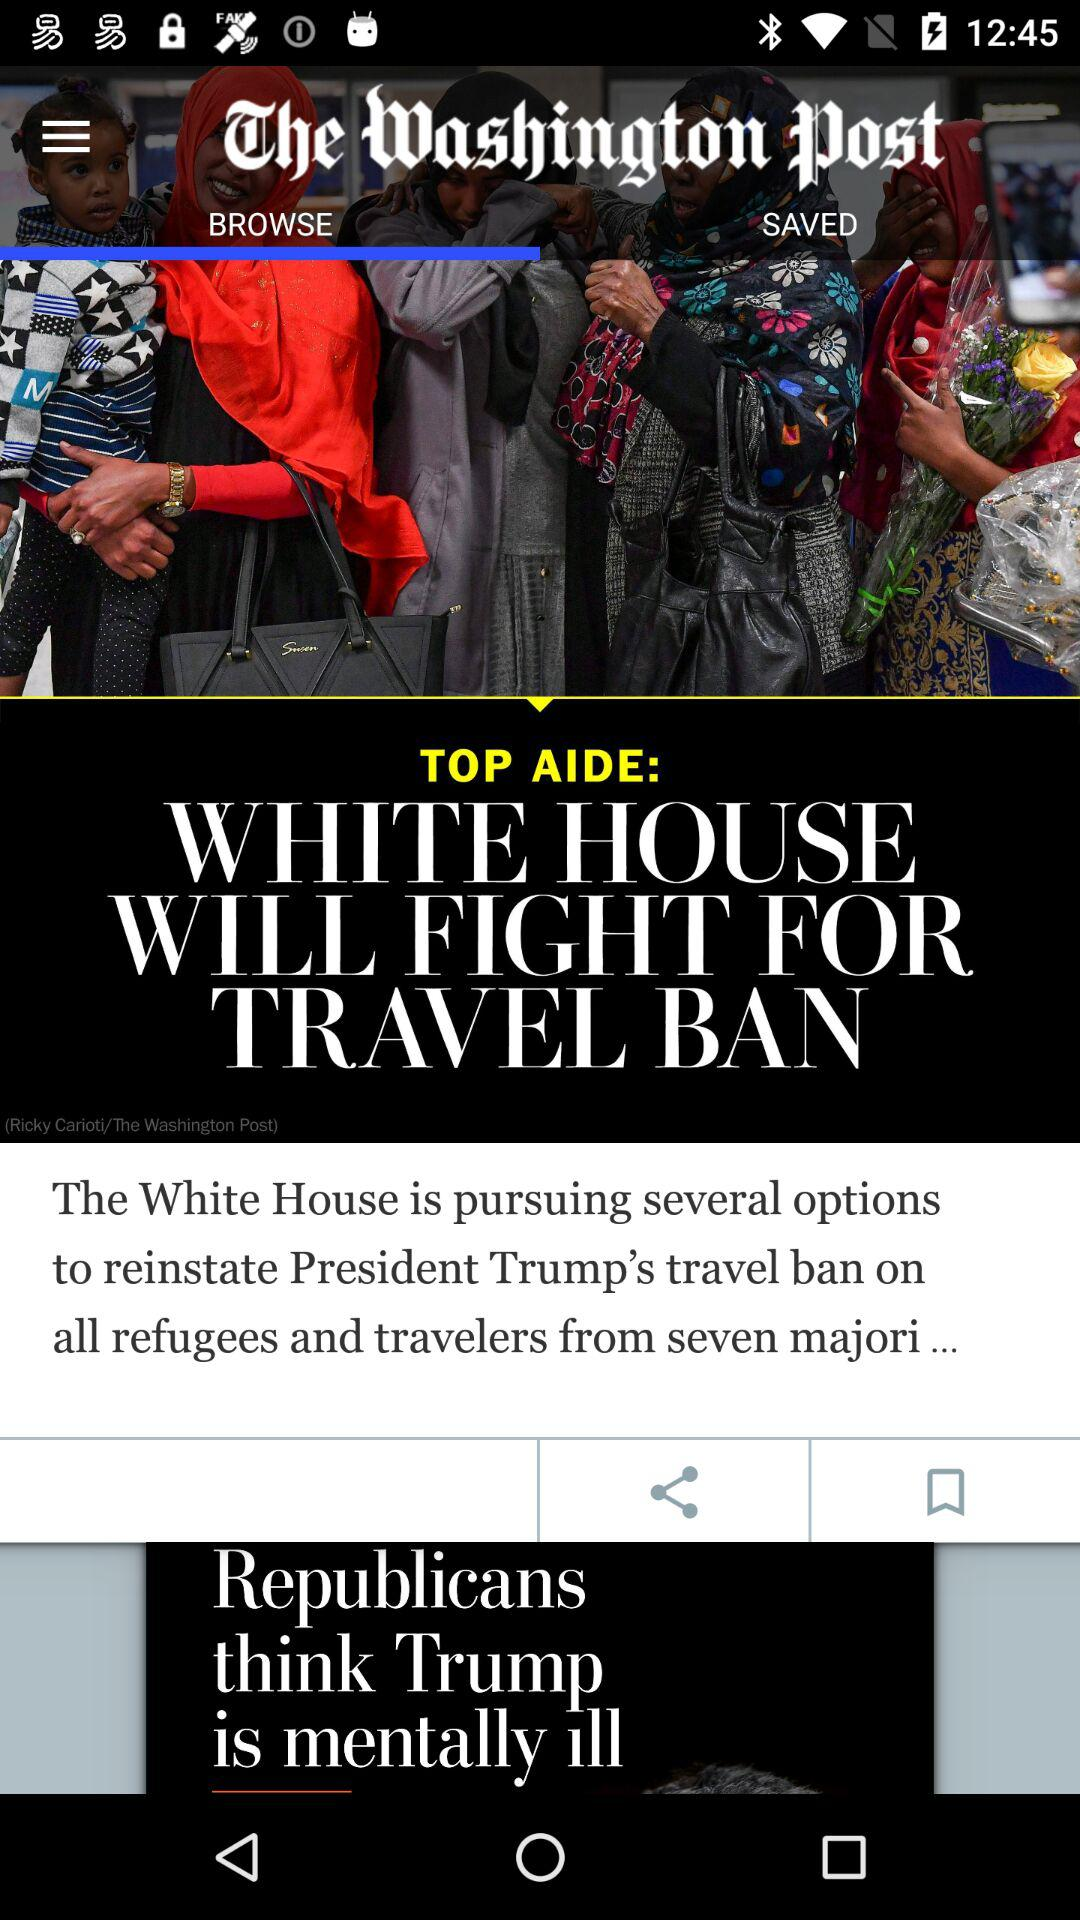What is the application name? The application name is "The Washington Post". 